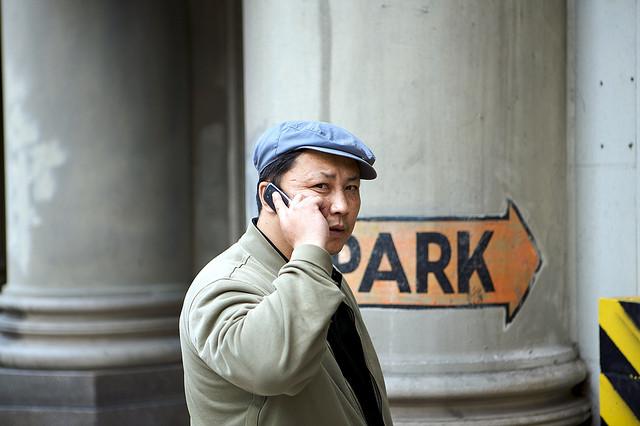Which hand holds the phone?
Short answer required. Right. What color is his cap?
Give a very brief answer. Blue. What does the sign behind the man say?
Write a very short answer. Park. Which way is the man facing?
Keep it brief. Right. 